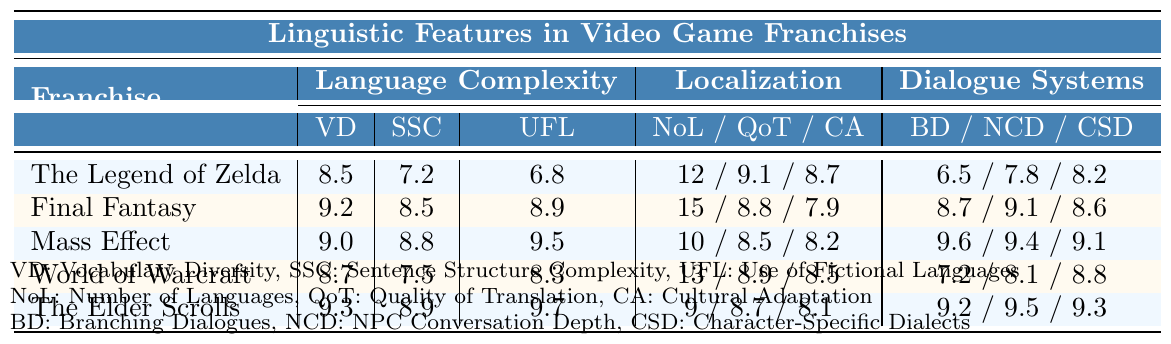What is the franchise with the highest vocabulary diversity? The table shows that "Final Fantasy" has the highest vocabulary diversity score of 9.2 among the franchises listed.
Answer: Final Fantasy How many languages is "The Elder Scrolls" localized into? The table indicates that "The Elder Scrolls" has been localized into 9 languages.
Answer: 9 What is the quality of translation for "Mass Effect"? According to the table, the quality of translation for "Mass Effect" is rated at 8.5.
Answer: 8.5 Which franchise has the lowest score for character-specific dialects? From the table, "The Legend of Zelda" has the lowest score for character-specific dialects at 8.2.
Answer: The Legend of Zelda How many more languages does "Final Fantasy" support compared to "The Elder Scrolls"? "Final Fantasy" supports 15 languages, and "The Elder Scrolls" supports 9 languages. The difference is 15 - 9 = 6 languages.
Answer: 6 What is the average sentence structure complexity of the franchises listed? The scores for sentence structure complexity are 7.2, 8.5, 8.8, 7.5, and 8.9. Summing these gives 40.9, and averaging over 5 franchises results in 40.9/5 = 8.18.
Answer: 8.18 Is "World of Warcraft" ranked higher for NPC conversation depth compared to "The Legend of Zelda"? "World of Warcraft" has an NPC conversation depth score of 8.1, while "The Legend of Zelda" has a score of 7.8, making "World of Warcraft" higher.
Answer: Yes Which franchise has the highest use of fictional languages? The table shows that "Mass Effect" has the highest score for the use of fictional languages at 9.5.
Answer: Mass Effect What is the combined score of localization quality and cultural adaptation for "Final Fantasy"? The localization quality score for "Final Fantasy" is 8.8 and the cultural adaptation score is 7.9. Thus, the combined score is 8.8 + 7.9 = 16.7.
Answer: 16.7 How does the cultural adaptation of "World of Warcraft" compare to "The Elder Scrolls"? "World of Warcraft" has a cultural adaptation score of 8.5, while "The Elder Scrolls" has a score of 8.1. Therefore, "World of Warcraft" scores higher in cultural adaptation.
Answer: World of Warcraft 